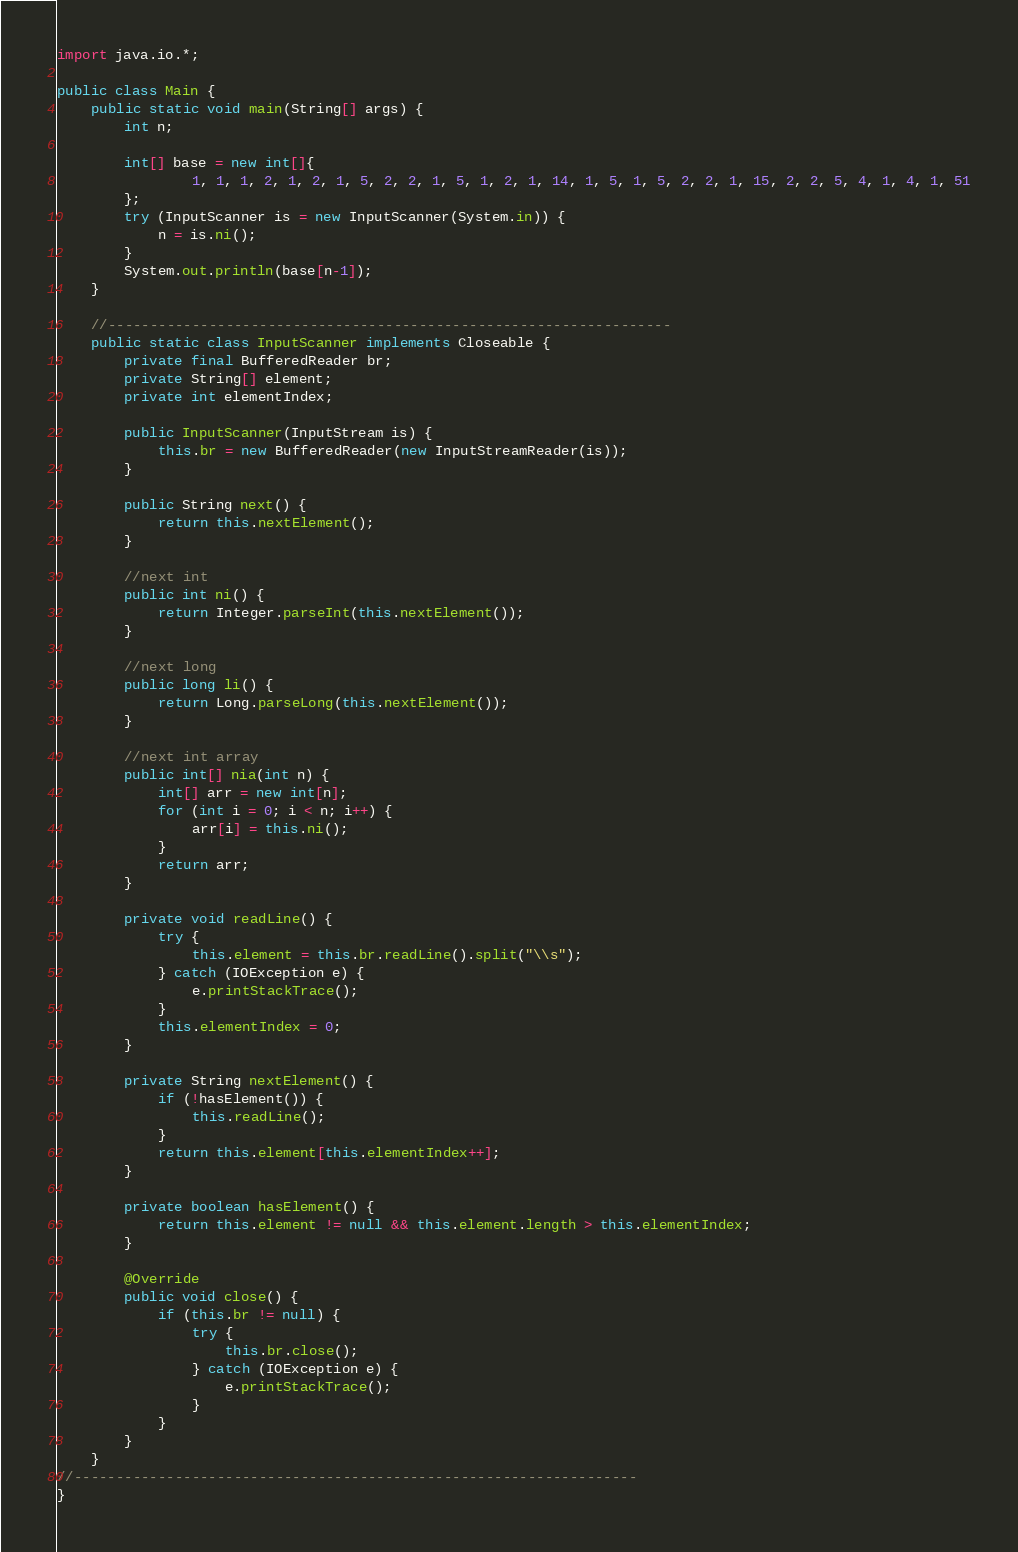Convert code to text. <code><loc_0><loc_0><loc_500><loc_500><_Java_>import java.io.*;

public class Main {
    public static void main(String[] args) {
        int n;

        int[] base = new int[]{
                1, 1, 1, 2, 1, 2, 1, 5, 2, 2, 1, 5, 1, 2, 1, 14, 1, 5, 1, 5, 2, 2, 1, 15, 2, 2, 5, 4, 1, 4, 1, 51
        };
        try (InputScanner is = new InputScanner(System.in)) {
            n = is.ni();
        }
        System.out.println(base[n-1]);
    }

    //-------------------------------------------------------------------
    public static class InputScanner implements Closeable {
        private final BufferedReader br;
        private String[] element;
        private int elementIndex;

        public InputScanner(InputStream is) {
            this.br = new BufferedReader(new InputStreamReader(is));
        }

        public String next() {
            return this.nextElement();
        }

        //next int
        public int ni() {
            return Integer.parseInt(this.nextElement());
        }

        //next long
        public long li() {
            return Long.parseLong(this.nextElement());
        }

        //next int array
        public int[] nia(int n) {
            int[] arr = new int[n];
            for (int i = 0; i < n; i++) {
                arr[i] = this.ni();
            }
            return arr;
        }

        private void readLine() {
            try {
                this.element = this.br.readLine().split("\\s");
            } catch (IOException e) {
                e.printStackTrace();
            }
            this.elementIndex = 0;
        }

        private String nextElement() {
            if (!hasElement()) {
                this.readLine();
            }
            return this.element[this.elementIndex++];
        }

        private boolean hasElement() {
            return this.element != null && this.element.length > this.elementIndex;
        }

        @Override
        public void close() {
            if (this.br != null) {
                try {
                    this.br.close();
                } catch (IOException e) {
                    e.printStackTrace();
                }
            }
        }
    }
//-------------------------------------------------------------------
}
</code> 